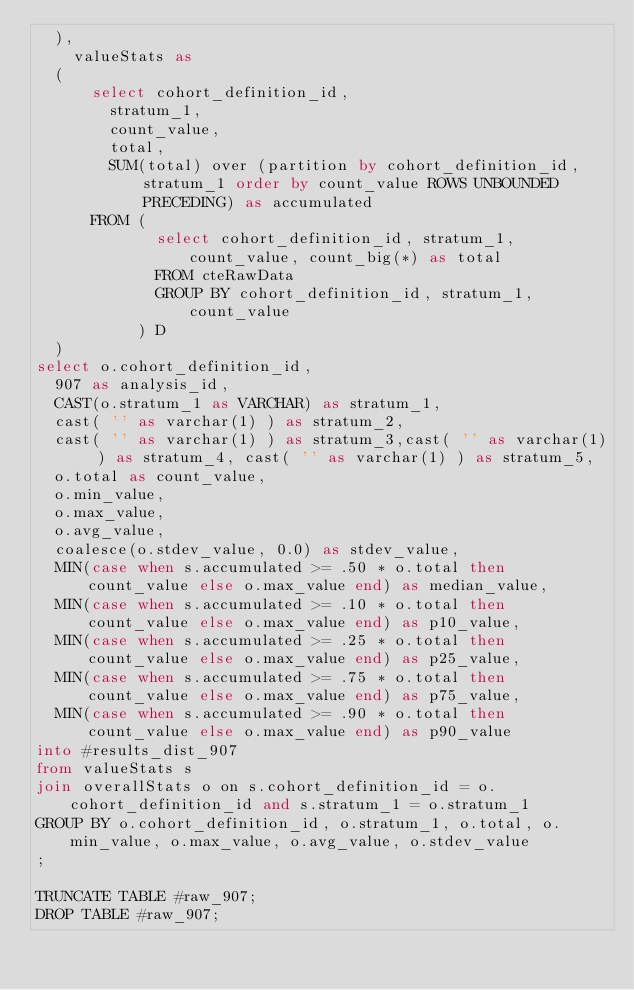Convert code to text. <code><loc_0><loc_0><loc_500><loc_500><_SQL_>  ),
    valueStats as
  (
      select cohort_definition_id,
        stratum_1,
        count_value,
        total,
        SUM(total) over (partition by cohort_definition_id, stratum_1 order by count_value ROWS UNBOUNDED PRECEDING) as accumulated
      FROM (
             select cohort_definition_id, stratum_1, count_value, count_big(*) as total
             FROM cteRawData
             GROUP BY cohort_definition_id, stratum_1, count_value
           ) D
  )
select o.cohort_definition_id,
  907 as analysis_id,
  CAST(o.stratum_1 as VARCHAR) as stratum_1,
  cast( '' as varchar(1) ) as stratum_2,
  cast( '' as varchar(1) ) as stratum_3,cast( '' as varchar(1) ) as stratum_4, cast( '' as varchar(1) ) as stratum_5,
  o.total as count_value,
  o.min_value,
  o.max_value,
  o.avg_value,
  coalesce(o.stdev_value, 0.0) as stdev_value,
  MIN(case when s.accumulated >= .50 * o.total then count_value else o.max_value end) as median_value,
  MIN(case when s.accumulated >= .10 * o.total then count_value else o.max_value end) as p10_value,
  MIN(case when s.accumulated >= .25 * o.total then count_value else o.max_value end) as p25_value,
  MIN(case when s.accumulated >= .75 * o.total then count_value else o.max_value end) as p75_value,
  MIN(case when s.accumulated >= .90 * o.total then count_value else o.max_value end) as p90_value
into #results_dist_907
from valueStats s
join overallStats o on s.cohort_definition_id = o.cohort_definition_id and s.stratum_1 = o.stratum_1
GROUP BY o.cohort_definition_id, o.stratum_1, o.total, o.min_value, o.max_value, o.avg_value, o.stdev_value
;

TRUNCATE TABLE #raw_907;
DROP TABLE #raw_907;</code> 